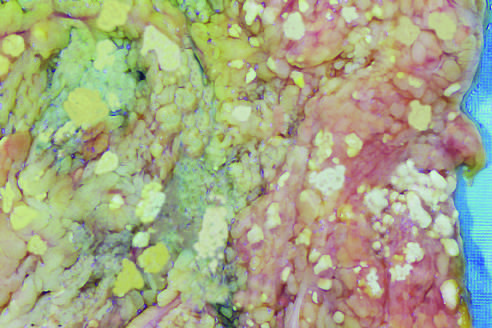do the histone subunits represent foci of fat necrosis with calcium soap formation at sites of lipid breakdown in the mesentery?
Answer the question using a single word or phrase. No 